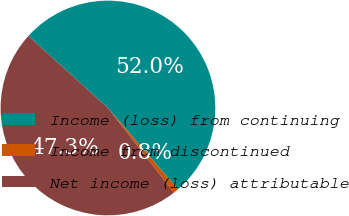<chart> <loc_0><loc_0><loc_500><loc_500><pie_chart><fcel>Income (loss) from continuing<fcel>Income from discontinued<fcel>Net income (loss) attributable<nl><fcel>51.98%<fcel>0.76%<fcel>47.26%<nl></chart> 